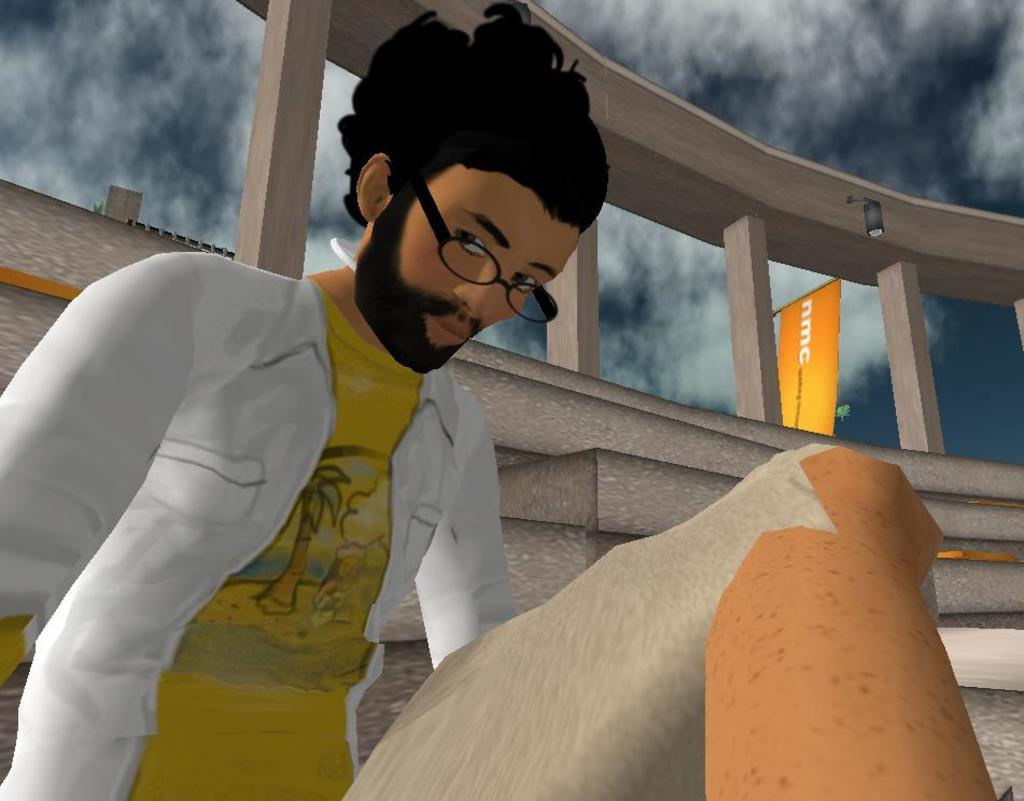What type of image is being described? The image is an animation and graphic. Can you describe the main subject in the image? There is a man sitting in the center of the image. What can be seen in the background of the image? There is a wall and a flag in the background of the image. How would you describe the weather in the image? The sky is cloudy in the image. How many chairs are visible in the image? There are no chairs present in the image. What type of ear is visible on the man in the image? There is no ear visible on the man in the image, as it is an animation and graphic. 